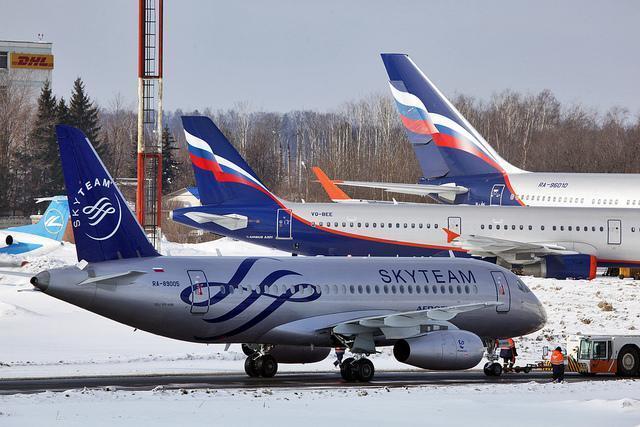How many airplanes can be seen?
Give a very brief answer. 4. How many birds are in the picture?
Give a very brief answer. 0. 